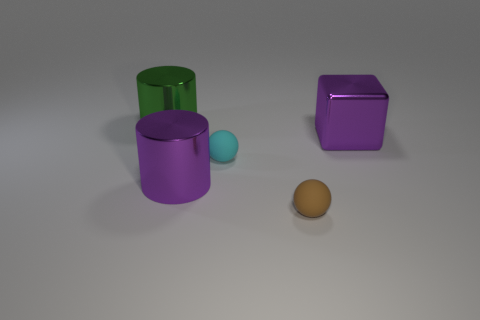Is there a small purple matte thing?
Your answer should be compact. No. There is a cylinder in front of the purple object that is right of the large purple shiny cylinder; what is its size?
Offer a terse response. Large. Does the object that is behind the purple block have the same color as the cylinder in front of the big purple metal cube?
Make the answer very short. No. There is a big thing that is both on the left side of the small brown rubber thing and in front of the green cylinder; what color is it?
Provide a succinct answer. Purple. What number of other objects are the same shape as the green object?
Ensure brevity in your answer.  1. There is another metallic cylinder that is the same size as the green metallic cylinder; what is its color?
Your response must be concise. Purple. The big object that is behind the large purple cube is what color?
Provide a succinct answer. Green. Are there any metal objects that are right of the sphere on the left side of the tiny brown sphere?
Your response must be concise. Yes. Do the tiny cyan object and the metal object that is on the right side of the tiny brown sphere have the same shape?
Provide a succinct answer. No. There is a object that is both in front of the cyan object and right of the cyan rubber thing; what is its size?
Offer a terse response. Small. 